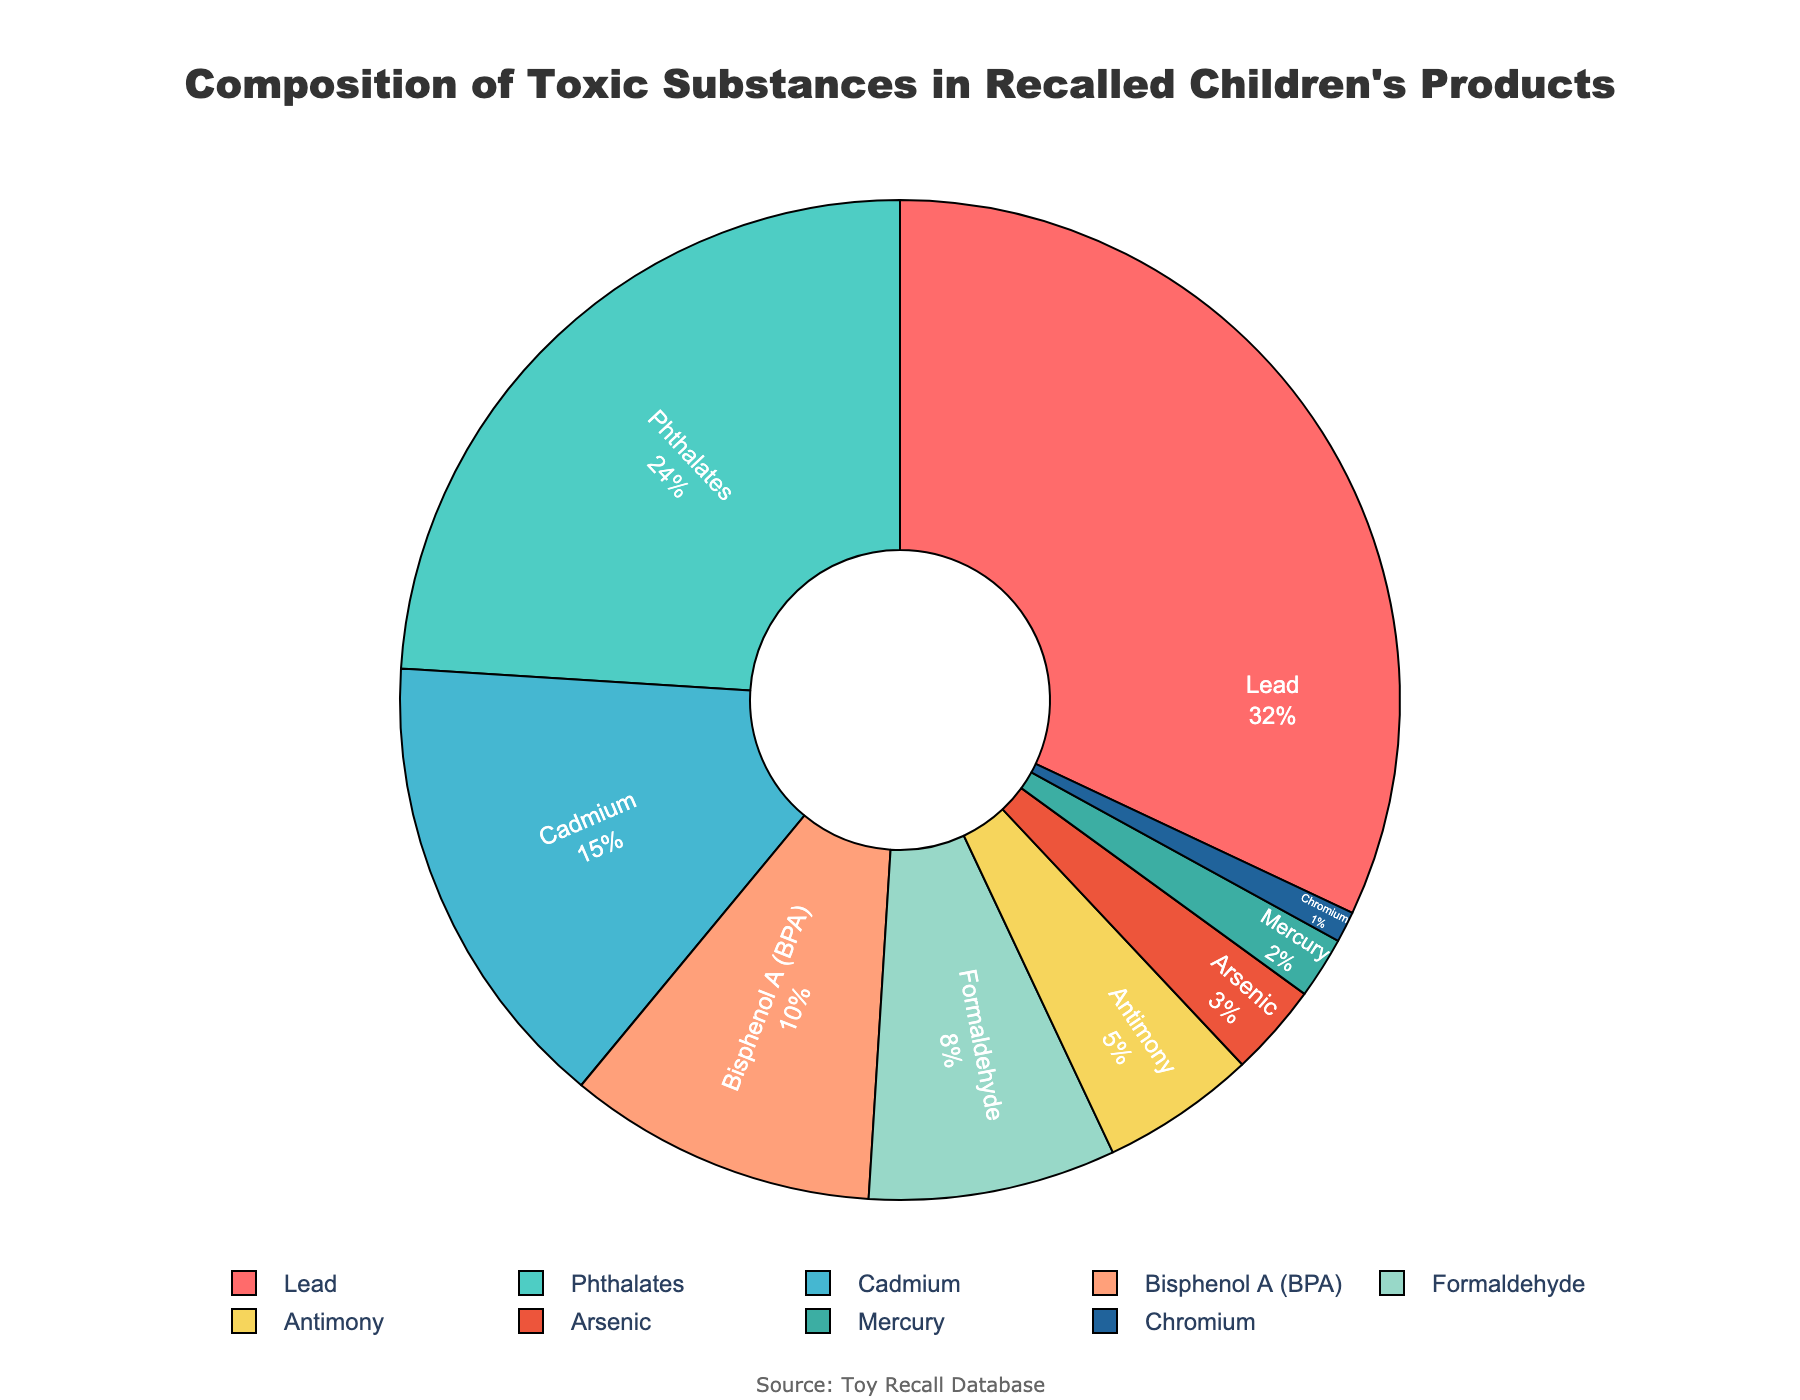What is the largest toxic substance in recalled children's products? Refer to the pie chart's slices to identify the section with the largest percentage. The largest slice is assigned to Lead with 32%.
Answer: Lead Which toxic substance has the smallest representation in the chart? Identify the slice with the smallest percentage. The slice representing Chromium is the smallest with only 1%.
Answer: Chromium What is the combined percentage of Lead and Phthalates found in recalled children's products? Refer to the pie chart to find the percentages for Lead (32%) and Phthalates (24%). Add these percentages together: 32% + 24% = 56%.
Answer: 56% How does the percentage of Cadmium compare to that of Bisphenol A (BPA)? Identify the slices for Cadmium and Bisphenol A (BPA). Cadmium is 15% and Bisphenol A (BPA) is 10%. Hence, Cadmium is higher by 5%.
Answer: Cadmium is higher by 5% What is the total percentage occupied by the three least common substances in the chart? Identify the three substances with the smallest percentages: Mercury (2%), Arsenic (3%), and Chromium (1%). Sum these percentages: 2% + 3% + 1% = 6%.
Answer: 6% Which substance has the closest percentage value to Formaldehyde? Identify the slice for Formaldehyde, which is 8%. Compare this with other substances. Antimony, having 5%, is the closest.
Answer: Antimony What is the difference in percentage between Antimony and Arsenic? Identify the slices for Antimony (5%) and Arsenic (3%). Subtract to find the difference: 5% - 3% = 2%.
Answer: 2% Rank the substances by their percentage in descending order. Refer to the chart and list the substances from the highest to the lowest percentage: Lead (32%), Phthalates (24%), Cadmium (15%), Bisphenol A (BPA) (10%), Formaldehyde (8%), Antimony (5%), Arsenic (3%), Mercury (2%), Chromium (1%).
Answer: Lead, Phthalates, Cadmium, Bisphenol A (BPA), Formaldehyde, Antimony, Arsenic, Mercury, Chromium Which color represents the largest percentage of toxic substances in the chart? Look for the slice representing the largest percentage, which is Lead at 32%, and identify its color, which is red.
Answer: Red Between Mercury and Chromium, which has a larger percentage, and what is the difference? Identify the slices for Mercury (2%) and Chromium (1%). Mercury has a larger percentage. The difference is 2% - 1% = 1%.
Answer: Mercury, 1% 